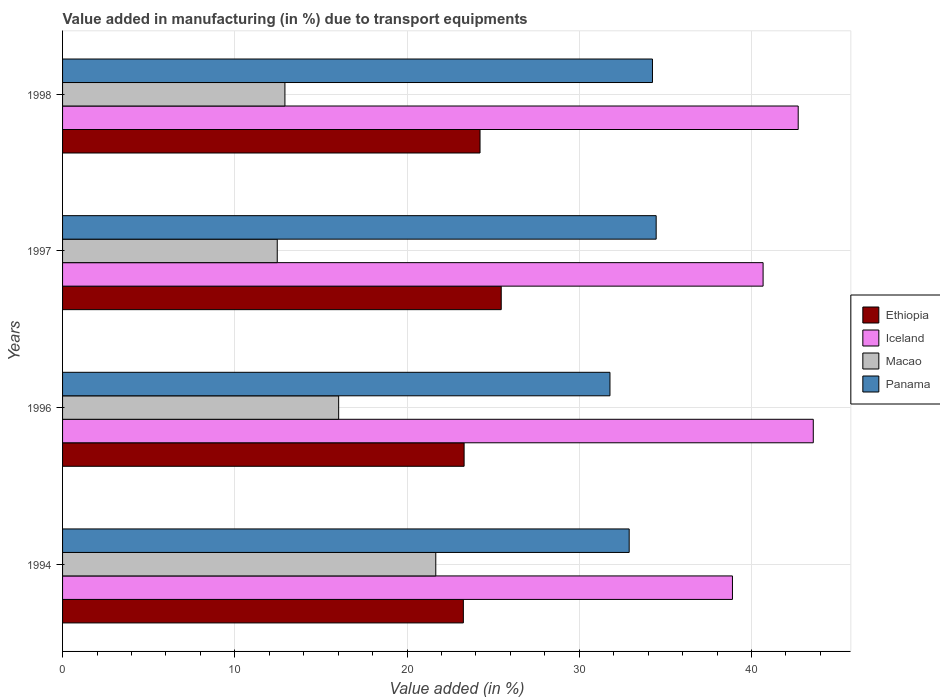How many different coloured bars are there?
Make the answer very short. 4. How many groups of bars are there?
Your answer should be very brief. 4. What is the label of the 2nd group of bars from the top?
Ensure brevity in your answer.  1997. What is the percentage of value added in manufacturing due to transport equipments in Panama in 1994?
Your response must be concise. 32.9. Across all years, what is the maximum percentage of value added in manufacturing due to transport equipments in Iceland?
Offer a terse response. 43.59. Across all years, what is the minimum percentage of value added in manufacturing due to transport equipments in Panama?
Your answer should be very brief. 31.78. In which year was the percentage of value added in manufacturing due to transport equipments in Panama maximum?
Give a very brief answer. 1997. What is the total percentage of value added in manufacturing due to transport equipments in Iceland in the graph?
Your response must be concise. 165.86. What is the difference between the percentage of value added in manufacturing due to transport equipments in Iceland in 1994 and that in 1998?
Offer a very short reply. -3.82. What is the difference between the percentage of value added in manufacturing due to transport equipments in Ethiopia in 1994 and the percentage of value added in manufacturing due to transport equipments in Macao in 1996?
Offer a very short reply. 7.24. What is the average percentage of value added in manufacturing due to transport equipments in Macao per year?
Your answer should be compact. 15.77. In the year 1997, what is the difference between the percentage of value added in manufacturing due to transport equipments in Panama and percentage of value added in manufacturing due to transport equipments in Ethiopia?
Offer a very short reply. 9. What is the ratio of the percentage of value added in manufacturing due to transport equipments in Panama in 1994 to that in 1996?
Keep it short and to the point. 1.04. Is the percentage of value added in manufacturing due to transport equipments in Panama in 1996 less than that in 1998?
Keep it short and to the point. Yes. Is the difference between the percentage of value added in manufacturing due to transport equipments in Panama in 1994 and 1996 greater than the difference between the percentage of value added in manufacturing due to transport equipments in Ethiopia in 1994 and 1996?
Offer a terse response. Yes. What is the difference between the highest and the second highest percentage of value added in manufacturing due to transport equipments in Iceland?
Give a very brief answer. 0.88. What is the difference between the highest and the lowest percentage of value added in manufacturing due to transport equipments in Macao?
Provide a short and direct response. 9.2. In how many years, is the percentage of value added in manufacturing due to transport equipments in Panama greater than the average percentage of value added in manufacturing due to transport equipments in Panama taken over all years?
Ensure brevity in your answer.  2. What does the 3rd bar from the top in 1994 represents?
Ensure brevity in your answer.  Iceland. How many bars are there?
Your answer should be very brief. 16. Are all the bars in the graph horizontal?
Your response must be concise. Yes. What is the difference between two consecutive major ticks on the X-axis?
Ensure brevity in your answer.  10. Does the graph contain grids?
Give a very brief answer. Yes. How many legend labels are there?
Give a very brief answer. 4. How are the legend labels stacked?
Provide a short and direct response. Vertical. What is the title of the graph?
Keep it short and to the point. Value added in manufacturing (in %) due to transport equipments. What is the label or title of the X-axis?
Give a very brief answer. Value added (in %). What is the Value added (in %) of Ethiopia in 1994?
Offer a terse response. 23.27. What is the Value added (in %) of Iceland in 1994?
Your answer should be compact. 38.89. What is the Value added (in %) of Macao in 1994?
Provide a short and direct response. 21.67. What is the Value added (in %) in Panama in 1994?
Provide a short and direct response. 32.9. What is the Value added (in %) in Ethiopia in 1996?
Give a very brief answer. 23.31. What is the Value added (in %) of Iceland in 1996?
Make the answer very short. 43.59. What is the Value added (in %) in Macao in 1996?
Your answer should be very brief. 16.03. What is the Value added (in %) of Panama in 1996?
Make the answer very short. 31.78. What is the Value added (in %) of Ethiopia in 1997?
Keep it short and to the point. 25.47. What is the Value added (in %) of Iceland in 1997?
Provide a short and direct response. 40.67. What is the Value added (in %) in Macao in 1997?
Your response must be concise. 12.46. What is the Value added (in %) in Panama in 1997?
Make the answer very short. 34.46. What is the Value added (in %) in Ethiopia in 1998?
Make the answer very short. 24.24. What is the Value added (in %) of Iceland in 1998?
Give a very brief answer. 42.71. What is the Value added (in %) of Macao in 1998?
Offer a terse response. 12.91. What is the Value added (in %) of Panama in 1998?
Offer a very short reply. 34.25. Across all years, what is the maximum Value added (in %) of Ethiopia?
Provide a succinct answer. 25.47. Across all years, what is the maximum Value added (in %) of Iceland?
Your answer should be compact. 43.59. Across all years, what is the maximum Value added (in %) of Macao?
Offer a very short reply. 21.67. Across all years, what is the maximum Value added (in %) in Panama?
Ensure brevity in your answer.  34.46. Across all years, what is the minimum Value added (in %) of Ethiopia?
Your answer should be compact. 23.27. Across all years, what is the minimum Value added (in %) in Iceland?
Provide a succinct answer. 38.89. Across all years, what is the minimum Value added (in %) of Macao?
Make the answer very short. 12.46. Across all years, what is the minimum Value added (in %) in Panama?
Make the answer very short. 31.78. What is the total Value added (in %) of Ethiopia in the graph?
Offer a very short reply. 96.29. What is the total Value added (in %) in Iceland in the graph?
Offer a terse response. 165.86. What is the total Value added (in %) in Macao in the graph?
Provide a short and direct response. 63.07. What is the total Value added (in %) of Panama in the graph?
Your response must be concise. 133.39. What is the difference between the Value added (in %) in Ethiopia in 1994 and that in 1996?
Provide a succinct answer. -0.04. What is the difference between the Value added (in %) of Iceland in 1994 and that in 1996?
Give a very brief answer. -4.69. What is the difference between the Value added (in %) in Macao in 1994 and that in 1996?
Your response must be concise. 5.64. What is the difference between the Value added (in %) in Panama in 1994 and that in 1996?
Your answer should be compact. 1.12. What is the difference between the Value added (in %) of Ethiopia in 1994 and that in 1997?
Make the answer very short. -2.2. What is the difference between the Value added (in %) of Iceland in 1994 and that in 1997?
Your answer should be very brief. -1.78. What is the difference between the Value added (in %) in Macao in 1994 and that in 1997?
Your response must be concise. 9.2. What is the difference between the Value added (in %) in Panama in 1994 and that in 1997?
Make the answer very short. -1.57. What is the difference between the Value added (in %) of Ethiopia in 1994 and that in 1998?
Provide a short and direct response. -0.97. What is the difference between the Value added (in %) in Iceland in 1994 and that in 1998?
Provide a succinct answer. -3.82. What is the difference between the Value added (in %) in Macao in 1994 and that in 1998?
Keep it short and to the point. 8.76. What is the difference between the Value added (in %) of Panama in 1994 and that in 1998?
Provide a succinct answer. -1.35. What is the difference between the Value added (in %) in Ethiopia in 1996 and that in 1997?
Provide a succinct answer. -2.16. What is the difference between the Value added (in %) of Iceland in 1996 and that in 1997?
Give a very brief answer. 2.91. What is the difference between the Value added (in %) in Macao in 1996 and that in 1997?
Your answer should be very brief. 3.57. What is the difference between the Value added (in %) in Panama in 1996 and that in 1997?
Your answer should be very brief. -2.68. What is the difference between the Value added (in %) of Ethiopia in 1996 and that in 1998?
Offer a very short reply. -0.92. What is the difference between the Value added (in %) of Iceland in 1996 and that in 1998?
Offer a very short reply. 0.88. What is the difference between the Value added (in %) in Macao in 1996 and that in 1998?
Your response must be concise. 3.12. What is the difference between the Value added (in %) of Panama in 1996 and that in 1998?
Ensure brevity in your answer.  -2.47. What is the difference between the Value added (in %) of Ethiopia in 1997 and that in 1998?
Provide a succinct answer. 1.23. What is the difference between the Value added (in %) of Iceland in 1997 and that in 1998?
Your answer should be very brief. -2.04. What is the difference between the Value added (in %) in Macao in 1997 and that in 1998?
Ensure brevity in your answer.  -0.45. What is the difference between the Value added (in %) of Panama in 1997 and that in 1998?
Your answer should be compact. 0.22. What is the difference between the Value added (in %) in Ethiopia in 1994 and the Value added (in %) in Iceland in 1996?
Offer a terse response. -20.32. What is the difference between the Value added (in %) in Ethiopia in 1994 and the Value added (in %) in Macao in 1996?
Ensure brevity in your answer.  7.24. What is the difference between the Value added (in %) in Ethiopia in 1994 and the Value added (in %) in Panama in 1996?
Your answer should be compact. -8.51. What is the difference between the Value added (in %) in Iceland in 1994 and the Value added (in %) in Macao in 1996?
Make the answer very short. 22.86. What is the difference between the Value added (in %) of Iceland in 1994 and the Value added (in %) of Panama in 1996?
Offer a very short reply. 7.11. What is the difference between the Value added (in %) in Macao in 1994 and the Value added (in %) in Panama in 1996?
Offer a very short reply. -10.11. What is the difference between the Value added (in %) of Ethiopia in 1994 and the Value added (in %) of Iceland in 1997?
Your response must be concise. -17.4. What is the difference between the Value added (in %) of Ethiopia in 1994 and the Value added (in %) of Macao in 1997?
Make the answer very short. 10.81. What is the difference between the Value added (in %) of Ethiopia in 1994 and the Value added (in %) of Panama in 1997?
Make the answer very short. -11.19. What is the difference between the Value added (in %) of Iceland in 1994 and the Value added (in %) of Macao in 1997?
Give a very brief answer. 26.43. What is the difference between the Value added (in %) of Iceland in 1994 and the Value added (in %) of Panama in 1997?
Give a very brief answer. 4.43. What is the difference between the Value added (in %) of Macao in 1994 and the Value added (in %) of Panama in 1997?
Give a very brief answer. -12.8. What is the difference between the Value added (in %) of Ethiopia in 1994 and the Value added (in %) of Iceland in 1998?
Your answer should be compact. -19.44. What is the difference between the Value added (in %) of Ethiopia in 1994 and the Value added (in %) of Macao in 1998?
Ensure brevity in your answer.  10.36. What is the difference between the Value added (in %) in Ethiopia in 1994 and the Value added (in %) in Panama in 1998?
Provide a succinct answer. -10.98. What is the difference between the Value added (in %) in Iceland in 1994 and the Value added (in %) in Macao in 1998?
Ensure brevity in your answer.  25.98. What is the difference between the Value added (in %) of Iceland in 1994 and the Value added (in %) of Panama in 1998?
Offer a very short reply. 4.64. What is the difference between the Value added (in %) in Macao in 1994 and the Value added (in %) in Panama in 1998?
Provide a short and direct response. -12.58. What is the difference between the Value added (in %) in Ethiopia in 1996 and the Value added (in %) in Iceland in 1997?
Your answer should be compact. -17.36. What is the difference between the Value added (in %) in Ethiopia in 1996 and the Value added (in %) in Macao in 1997?
Provide a short and direct response. 10.85. What is the difference between the Value added (in %) of Ethiopia in 1996 and the Value added (in %) of Panama in 1997?
Offer a terse response. -11.15. What is the difference between the Value added (in %) of Iceland in 1996 and the Value added (in %) of Macao in 1997?
Your answer should be compact. 31.12. What is the difference between the Value added (in %) in Iceland in 1996 and the Value added (in %) in Panama in 1997?
Give a very brief answer. 9.12. What is the difference between the Value added (in %) in Macao in 1996 and the Value added (in %) in Panama in 1997?
Offer a very short reply. -18.44. What is the difference between the Value added (in %) in Ethiopia in 1996 and the Value added (in %) in Iceland in 1998?
Your answer should be compact. -19.4. What is the difference between the Value added (in %) of Ethiopia in 1996 and the Value added (in %) of Macao in 1998?
Make the answer very short. 10.4. What is the difference between the Value added (in %) of Ethiopia in 1996 and the Value added (in %) of Panama in 1998?
Offer a terse response. -10.94. What is the difference between the Value added (in %) of Iceland in 1996 and the Value added (in %) of Macao in 1998?
Your answer should be very brief. 30.68. What is the difference between the Value added (in %) in Iceland in 1996 and the Value added (in %) in Panama in 1998?
Provide a short and direct response. 9.34. What is the difference between the Value added (in %) of Macao in 1996 and the Value added (in %) of Panama in 1998?
Provide a short and direct response. -18.22. What is the difference between the Value added (in %) in Ethiopia in 1997 and the Value added (in %) in Iceland in 1998?
Provide a short and direct response. -17.24. What is the difference between the Value added (in %) in Ethiopia in 1997 and the Value added (in %) in Macao in 1998?
Your answer should be compact. 12.56. What is the difference between the Value added (in %) of Ethiopia in 1997 and the Value added (in %) of Panama in 1998?
Keep it short and to the point. -8.78. What is the difference between the Value added (in %) in Iceland in 1997 and the Value added (in %) in Macao in 1998?
Keep it short and to the point. 27.76. What is the difference between the Value added (in %) of Iceland in 1997 and the Value added (in %) of Panama in 1998?
Ensure brevity in your answer.  6.42. What is the difference between the Value added (in %) in Macao in 1997 and the Value added (in %) in Panama in 1998?
Give a very brief answer. -21.79. What is the average Value added (in %) of Ethiopia per year?
Ensure brevity in your answer.  24.07. What is the average Value added (in %) of Iceland per year?
Provide a succinct answer. 41.47. What is the average Value added (in %) of Macao per year?
Provide a short and direct response. 15.77. What is the average Value added (in %) in Panama per year?
Your response must be concise. 33.35. In the year 1994, what is the difference between the Value added (in %) of Ethiopia and Value added (in %) of Iceland?
Offer a terse response. -15.62. In the year 1994, what is the difference between the Value added (in %) in Ethiopia and Value added (in %) in Macao?
Offer a very short reply. 1.6. In the year 1994, what is the difference between the Value added (in %) of Ethiopia and Value added (in %) of Panama?
Ensure brevity in your answer.  -9.63. In the year 1994, what is the difference between the Value added (in %) of Iceland and Value added (in %) of Macao?
Offer a very short reply. 17.22. In the year 1994, what is the difference between the Value added (in %) of Iceland and Value added (in %) of Panama?
Make the answer very short. 6. In the year 1994, what is the difference between the Value added (in %) of Macao and Value added (in %) of Panama?
Keep it short and to the point. -11.23. In the year 1996, what is the difference between the Value added (in %) in Ethiopia and Value added (in %) in Iceland?
Offer a very short reply. -20.27. In the year 1996, what is the difference between the Value added (in %) of Ethiopia and Value added (in %) of Macao?
Provide a short and direct response. 7.28. In the year 1996, what is the difference between the Value added (in %) in Ethiopia and Value added (in %) in Panama?
Offer a terse response. -8.47. In the year 1996, what is the difference between the Value added (in %) in Iceland and Value added (in %) in Macao?
Your response must be concise. 27.56. In the year 1996, what is the difference between the Value added (in %) of Iceland and Value added (in %) of Panama?
Offer a terse response. 11.8. In the year 1996, what is the difference between the Value added (in %) of Macao and Value added (in %) of Panama?
Make the answer very short. -15.75. In the year 1997, what is the difference between the Value added (in %) in Ethiopia and Value added (in %) in Iceland?
Offer a very short reply. -15.2. In the year 1997, what is the difference between the Value added (in %) in Ethiopia and Value added (in %) in Macao?
Ensure brevity in your answer.  13. In the year 1997, what is the difference between the Value added (in %) in Ethiopia and Value added (in %) in Panama?
Give a very brief answer. -9. In the year 1997, what is the difference between the Value added (in %) in Iceland and Value added (in %) in Macao?
Your response must be concise. 28.21. In the year 1997, what is the difference between the Value added (in %) of Iceland and Value added (in %) of Panama?
Provide a short and direct response. 6.21. In the year 1997, what is the difference between the Value added (in %) in Macao and Value added (in %) in Panama?
Provide a succinct answer. -22. In the year 1998, what is the difference between the Value added (in %) of Ethiopia and Value added (in %) of Iceland?
Your answer should be very brief. -18.47. In the year 1998, what is the difference between the Value added (in %) of Ethiopia and Value added (in %) of Macao?
Give a very brief answer. 11.33. In the year 1998, what is the difference between the Value added (in %) in Ethiopia and Value added (in %) in Panama?
Offer a very short reply. -10.01. In the year 1998, what is the difference between the Value added (in %) of Iceland and Value added (in %) of Macao?
Keep it short and to the point. 29.8. In the year 1998, what is the difference between the Value added (in %) of Iceland and Value added (in %) of Panama?
Your response must be concise. 8.46. In the year 1998, what is the difference between the Value added (in %) of Macao and Value added (in %) of Panama?
Provide a short and direct response. -21.34. What is the ratio of the Value added (in %) in Ethiopia in 1994 to that in 1996?
Provide a succinct answer. 1. What is the ratio of the Value added (in %) in Iceland in 1994 to that in 1996?
Ensure brevity in your answer.  0.89. What is the ratio of the Value added (in %) of Macao in 1994 to that in 1996?
Your answer should be compact. 1.35. What is the ratio of the Value added (in %) in Panama in 1994 to that in 1996?
Your response must be concise. 1.04. What is the ratio of the Value added (in %) of Ethiopia in 1994 to that in 1997?
Give a very brief answer. 0.91. What is the ratio of the Value added (in %) of Iceland in 1994 to that in 1997?
Your answer should be very brief. 0.96. What is the ratio of the Value added (in %) in Macao in 1994 to that in 1997?
Provide a succinct answer. 1.74. What is the ratio of the Value added (in %) of Panama in 1994 to that in 1997?
Provide a short and direct response. 0.95. What is the ratio of the Value added (in %) in Ethiopia in 1994 to that in 1998?
Give a very brief answer. 0.96. What is the ratio of the Value added (in %) in Iceland in 1994 to that in 1998?
Keep it short and to the point. 0.91. What is the ratio of the Value added (in %) of Macao in 1994 to that in 1998?
Offer a very short reply. 1.68. What is the ratio of the Value added (in %) in Panama in 1994 to that in 1998?
Offer a terse response. 0.96. What is the ratio of the Value added (in %) in Ethiopia in 1996 to that in 1997?
Provide a succinct answer. 0.92. What is the ratio of the Value added (in %) of Iceland in 1996 to that in 1997?
Keep it short and to the point. 1.07. What is the ratio of the Value added (in %) of Macao in 1996 to that in 1997?
Keep it short and to the point. 1.29. What is the ratio of the Value added (in %) of Panama in 1996 to that in 1997?
Give a very brief answer. 0.92. What is the ratio of the Value added (in %) in Ethiopia in 1996 to that in 1998?
Your answer should be compact. 0.96. What is the ratio of the Value added (in %) of Iceland in 1996 to that in 1998?
Provide a short and direct response. 1.02. What is the ratio of the Value added (in %) in Macao in 1996 to that in 1998?
Your answer should be compact. 1.24. What is the ratio of the Value added (in %) in Panama in 1996 to that in 1998?
Give a very brief answer. 0.93. What is the ratio of the Value added (in %) in Ethiopia in 1997 to that in 1998?
Give a very brief answer. 1.05. What is the ratio of the Value added (in %) in Iceland in 1997 to that in 1998?
Your answer should be compact. 0.95. What is the ratio of the Value added (in %) of Macao in 1997 to that in 1998?
Make the answer very short. 0.97. What is the ratio of the Value added (in %) of Panama in 1997 to that in 1998?
Ensure brevity in your answer.  1.01. What is the difference between the highest and the second highest Value added (in %) in Ethiopia?
Your answer should be very brief. 1.23. What is the difference between the highest and the second highest Value added (in %) of Iceland?
Provide a succinct answer. 0.88. What is the difference between the highest and the second highest Value added (in %) in Macao?
Ensure brevity in your answer.  5.64. What is the difference between the highest and the second highest Value added (in %) in Panama?
Provide a succinct answer. 0.22. What is the difference between the highest and the lowest Value added (in %) in Ethiopia?
Your response must be concise. 2.2. What is the difference between the highest and the lowest Value added (in %) of Iceland?
Keep it short and to the point. 4.69. What is the difference between the highest and the lowest Value added (in %) of Macao?
Offer a terse response. 9.2. What is the difference between the highest and the lowest Value added (in %) in Panama?
Provide a succinct answer. 2.68. 